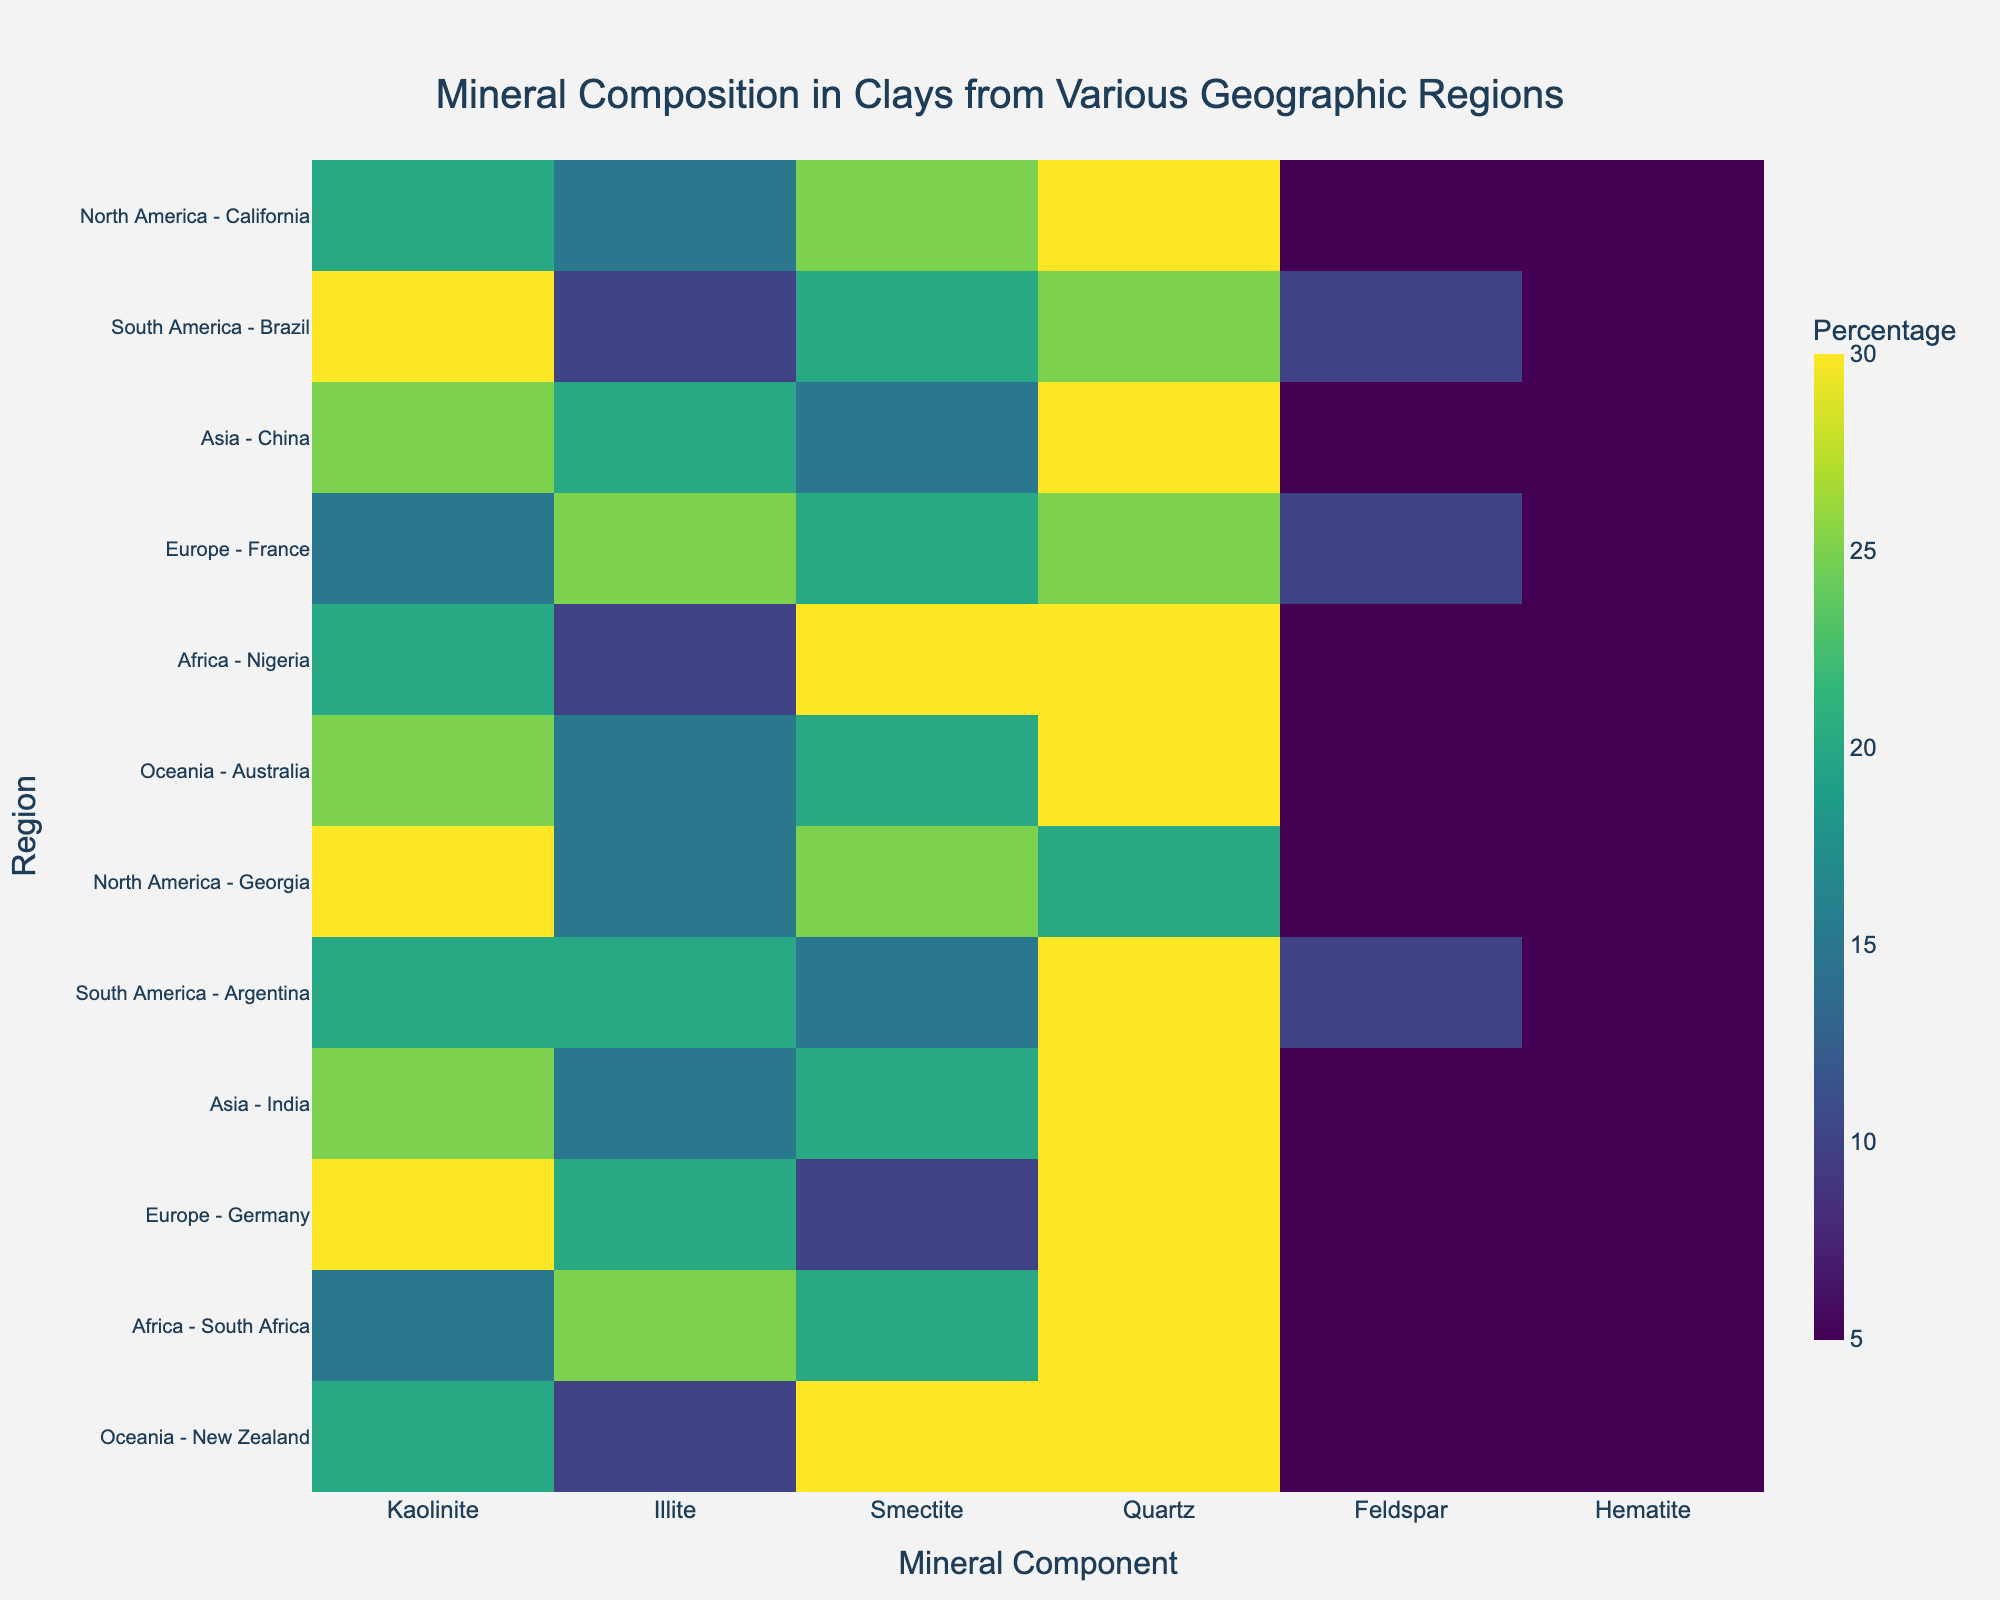What regions are represented in the heatmap? In the heatmap, regions can be identified by the combination of geographical regions and specific mineral sources indicated on the vertical axis. The regions represented are North America, South America, Asia, Europe, Africa, and Oceania.
Answer: North America, South America, Asia, Europe, Africa, Oceania Which region has the highest percentage of Kaolinite in any of its clays? To identify this, look at the columns representing Kaolinite across different regions. The highest percentage is in Georgia, a region in North America, at 30%.
Answer: Georgia How do the Kaolinite percentages compare between regions from Africa? Referring to the heatmap columns for Kaolinite in African regions, Nigeria has 20% and South Africa has 15%. Thus, Nigeria has a higher percentage of Kaolinite.
Answer: Nigeria has more Which mineral shows the least variation across all regions? To determine this, compare the range of percentages for each mineral across all regions. Feldspar has a consistent 5-10% across all regions, indicating the least variation.
Answer: Feldspar What is the average percentage of Quartz in regions from Asia? To calculate the average, locate the Quartz percentages for the regions in Asia: China (30), and India (30). Add these values and divide by the number of regions: (30+30)/2 = 30.
Answer: 30 Which regions have an equal percentage of Smectite? By comparing the Smectite columns, regions with equal percentages of 25% include California and Georgia in North America. Regions with 20% include Australia and India. Regions with 30% include Nigeria and New Zealand.
Answer: California & Georgia, Australia & India, Nigeria & New Zealand Is there a region where Illite forms the highest percentage among all minerals? To find this, compare the percentage values within each region for Illite. In France, Europe, Illite has the highest percentage among the minerals at 25%.
Answer: France Between China and Germany, which region has a higher diversity in mineral composition based on the percentage spread? Diversity can be estimated by the range (difference between the highest and lowest values). For China: range (30-5=25). For Germany: range (30-5=25). Since both have the same range, their diversity in mineral composition is equal.
Answer: Equal diversity What percentage of minerals in South America, Brazil, is not Quartz or Feldspar? First, identify the Quartz (25%) and Feldspar (10%) percentages. Sum these to get 35%. Subtract from 100% to find the percentage of other minerals: 100 - 35 = 65%.
Answer: 65 In which geographical region do all regions have the same amount of Hematite? Referring to the Hematite column, observe the percentages. All regions in Asia (China and India) have exactly 5% Hematite.
Answer: Asia 